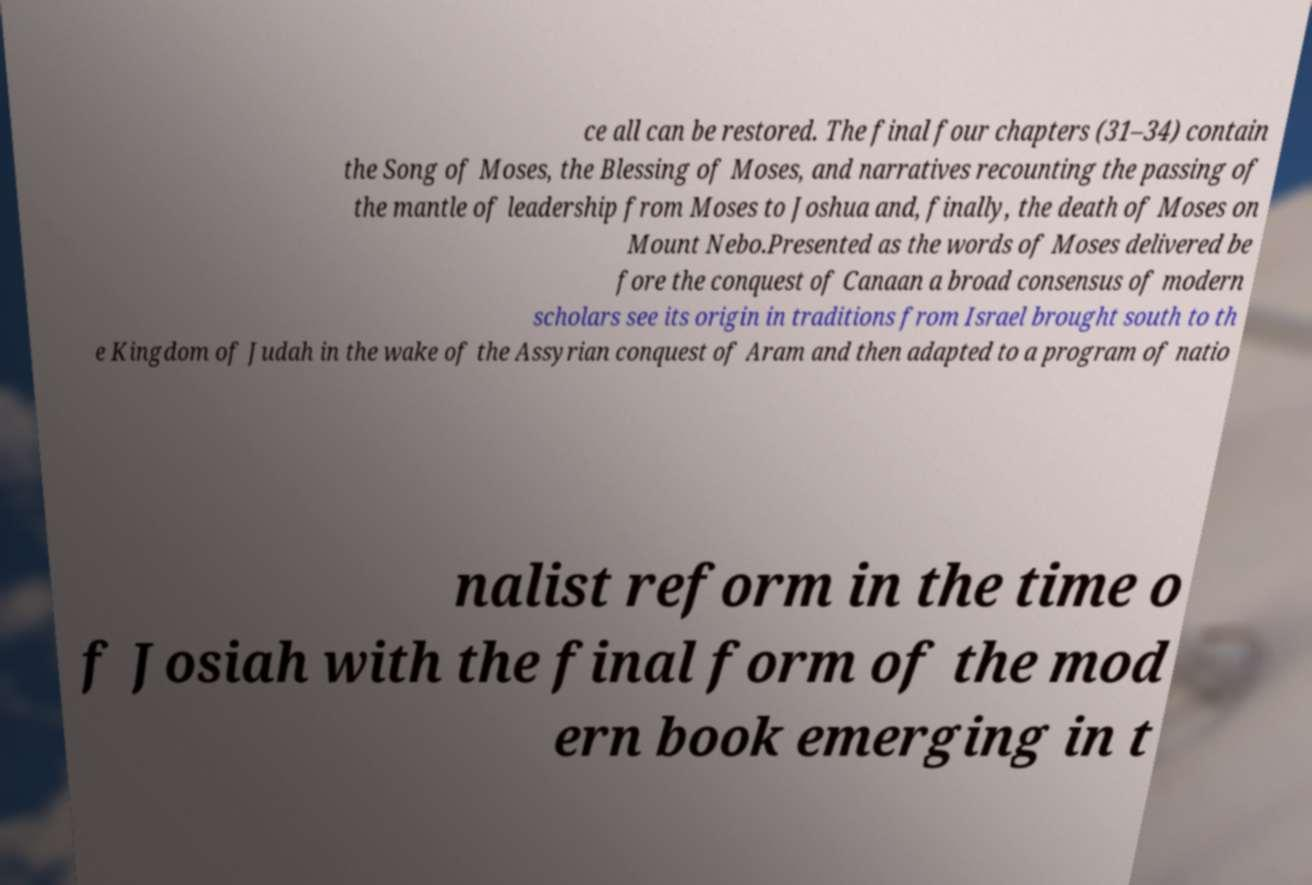I need the written content from this picture converted into text. Can you do that? ce all can be restored. The final four chapters (31–34) contain the Song of Moses, the Blessing of Moses, and narratives recounting the passing of the mantle of leadership from Moses to Joshua and, finally, the death of Moses on Mount Nebo.Presented as the words of Moses delivered be fore the conquest of Canaan a broad consensus of modern scholars see its origin in traditions from Israel brought south to th e Kingdom of Judah in the wake of the Assyrian conquest of Aram and then adapted to a program of natio nalist reform in the time o f Josiah with the final form of the mod ern book emerging in t 